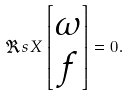<formula> <loc_0><loc_0><loc_500><loc_500>\Re s X \left [ \begin{matrix} \omega \\ f \end{matrix} \right ] = 0 .</formula> 